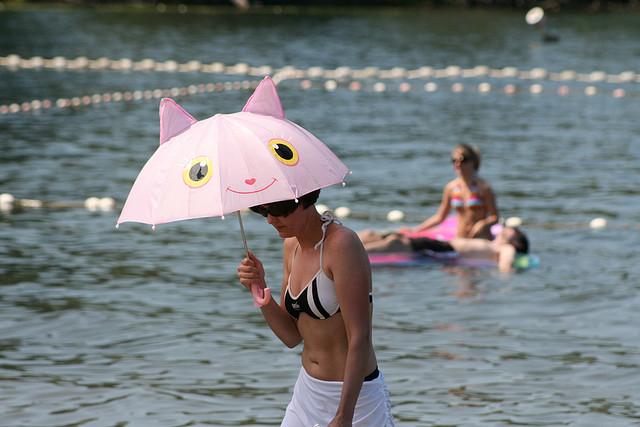What is the boy laying on in the background?
Be succinct. Float. What animal is the umbrella?
Give a very brief answer. Cat. Is it raining?
Answer briefly. No. 